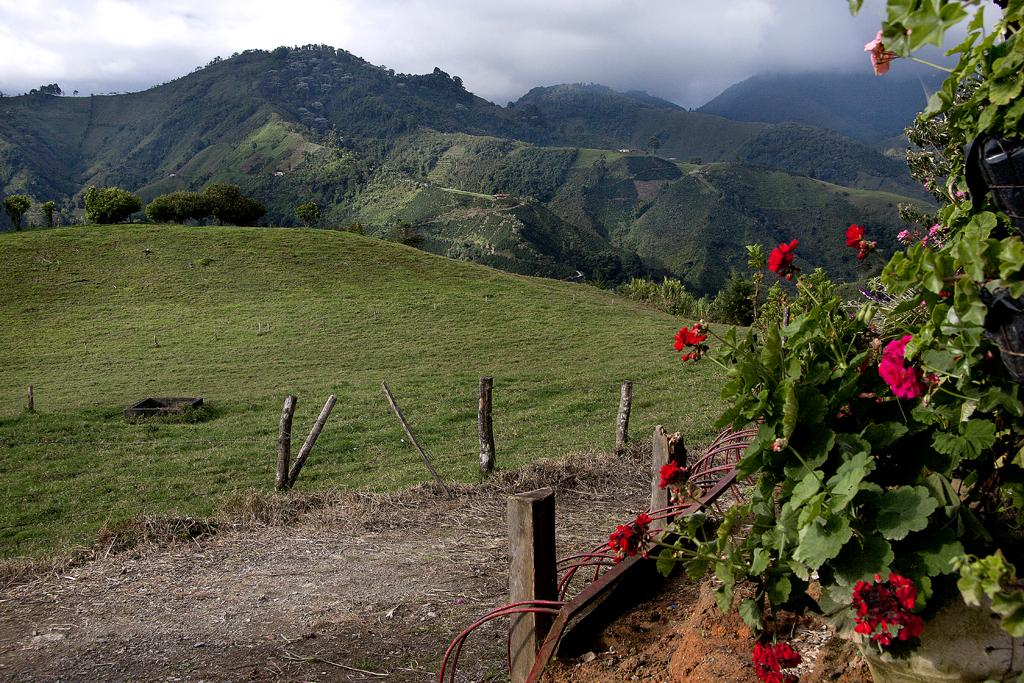What type of plants can be seen in the image? There are flower plants in the image. What material are the poles made of in the image? The poles in the image are made of wood. What type of vegetation is visible in the image? Grass is visible in the image. What can be seen in the background of the image? Hills and trees are visible in the background of the image. What is the source of the smoke in the image? The source of the smoke is not specified in the image. What part of the natural environment is visible in the image? The sky is visible in the image. Where is the cobweb located in the image? There is no cobweb present in the image. What type of exchange is taking place between the trees in the image? There is no exchange taking place between the trees in the image; they are stationary. 